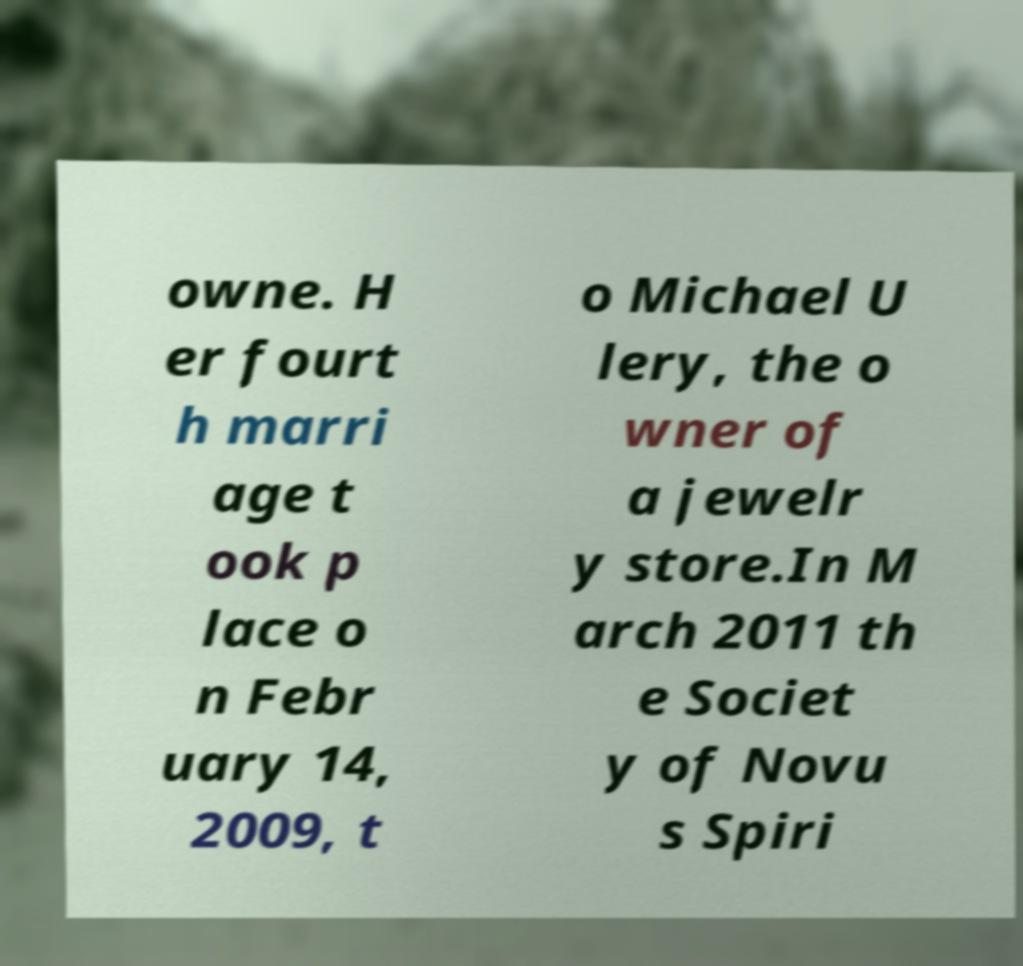Please read and relay the text visible in this image. What does it say? owne. H er fourt h marri age t ook p lace o n Febr uary 14, 2009, t o Michael U lery, the o wner of a jewelr y store.In M arch 2011 th e Societ y of Novu s Spiri 